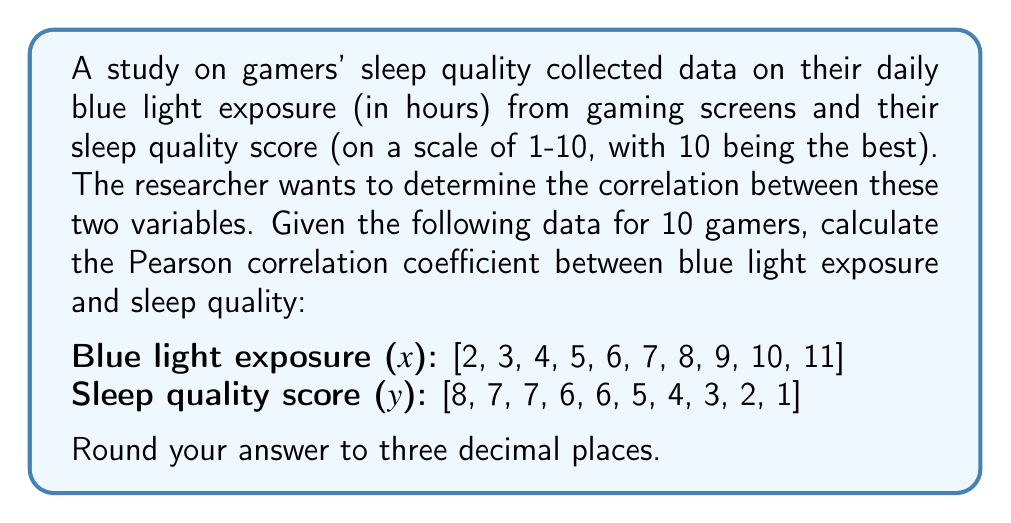Help me with this question. To calculate the Pearson correlation coefficient (r), we'll use the formula:

$$ r = \frac{n\sum xy - \sum x \sum y}{\sqrt{[n\sum x^2 - (\sum x)^2][n\sum y^2 - (\sum y)^2]}} $$

Where:
n = number of pairs of data
x = blue light exposure hours
y = sleep quality score

Step 1: Calculate the required sums:
n = 10
$\sum x = 55$
$\sum y = 49$
$\sum xy = 245$
$\sum x^2 = 385$
$\sum y^2 = 301$

Step 2: Calculate $(\sum x)^2$ and $(\sum y)^2$:
$(\sum x)^2 = 55^2 = 3025$
$(\sum y)^2 = 49^2 = 2401$

Step 3: Apply the formula:

$$ r = \frac{10(245) - (55)(49)}{\sqrt{[10(385) - 3025][10(301) - 2401]}} $$

$$ r = \frac{2450 - 2695}{\sqrt{(3850 - 3025)(3010 - 2401)}} $$

$$ r = \frac{-245}{\sqrt{(825)(609)}} $$

$$ r = \frac{-245}{\sqrt{502425}} $$

$$ r = \frac{-245}{708.8181...} $$

$$ r = -0.345651... $$

Step 4: Round to three decimal places:
r ≈ -0.346
Answer: -0.346 